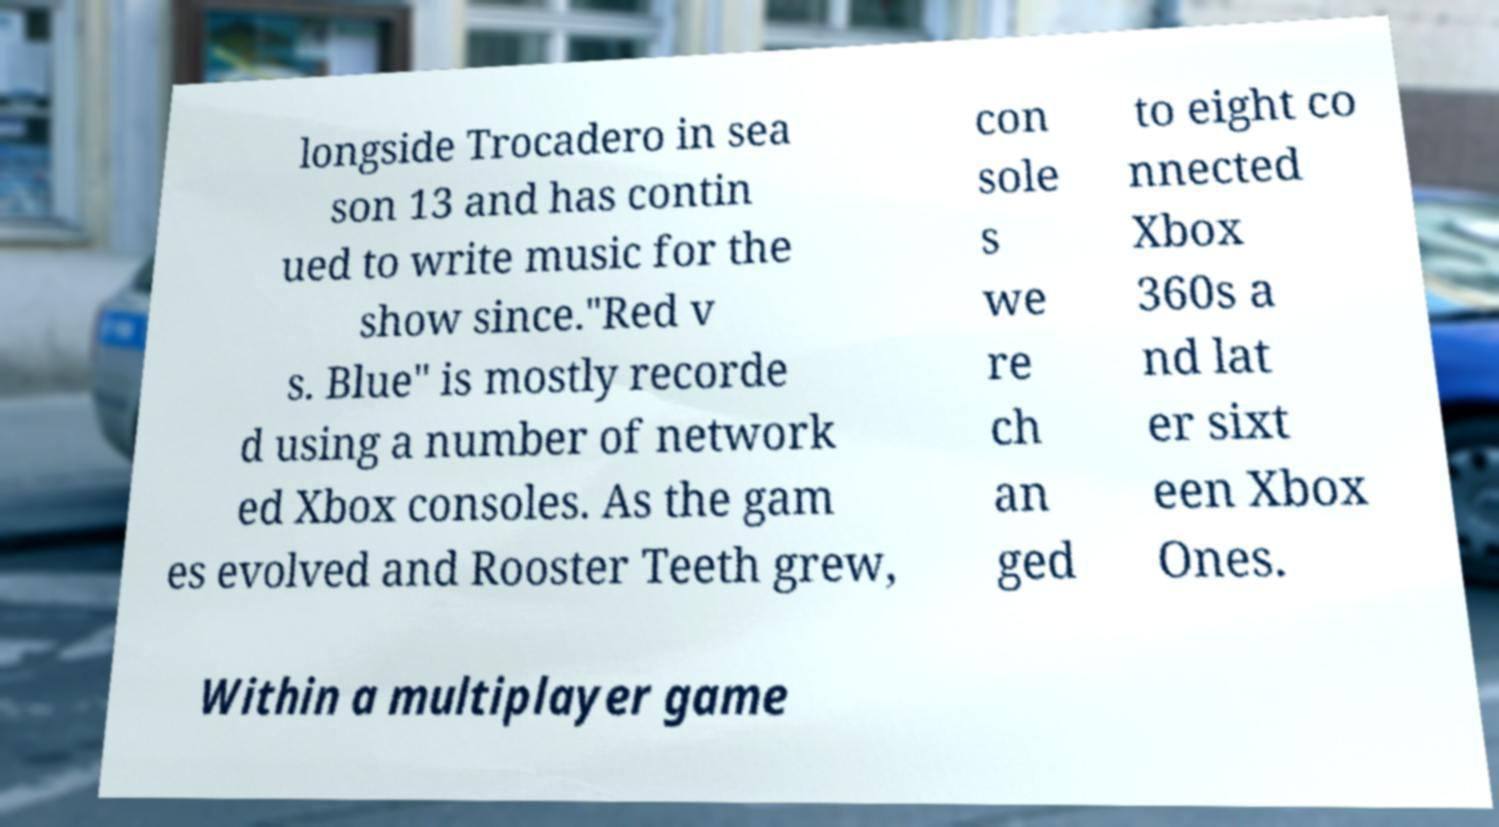For documentation purposes, I need the text within this image transcribed. Could you provide that? longside Trocadero in sea son 13 and has contin ued to write music for the show since."Red v s. Blue" is mostly recorde d using a number of network ed Xbox consoles. As the gam es evolved and Rooster Teeth grew, con sole s we re ch an ged to eight co nnected Xbox 360s a nd lat er sixt een Xbox Ones. Within a multiplayer game 